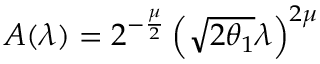Convert formula to latex. <formula><loc_0><loc_0><loc_500><loc_500>A ( \lambda ) = 2 ^ { - \frac { \mu } { 2 } } \left ( \sqrt { 2 \theta _ { 1 } } \lambda \right ) ^ { 2 \mu }</formula> 